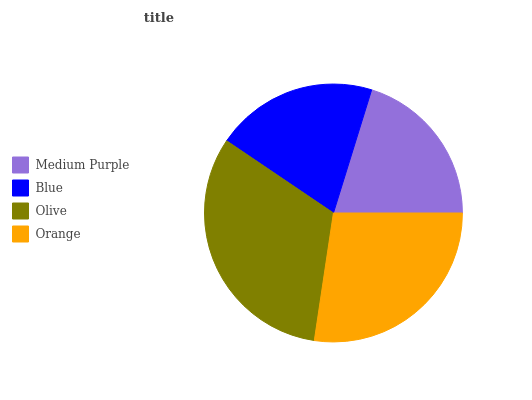Is Medium Purple the minimum?
Answer yes or no. Yes. Is Olive the maximum?
Answer yes or no. Yes. Is Blue the minimum?
Answer yes or no. No. Is Blue the maximum?
Answer yes or no. No. Is Blue greater than Medium Purple?
Answer yes or no. Yes. Is Medium Purple less than Blue?
Answer yes or no. Yes. Is Medium Purple greater than Blue?
Answer yes or no. No. Is Blue less than Medium Purple?
Answer yes or no. No. Is Orange the high median?
Answer yes or no. Yes. Is Blue the low median?
Answer yes or no. Yes. Is Blue the high median?
Answer yes or no. No. Is Medium Purple the low median?
Answer yes or no. No. 